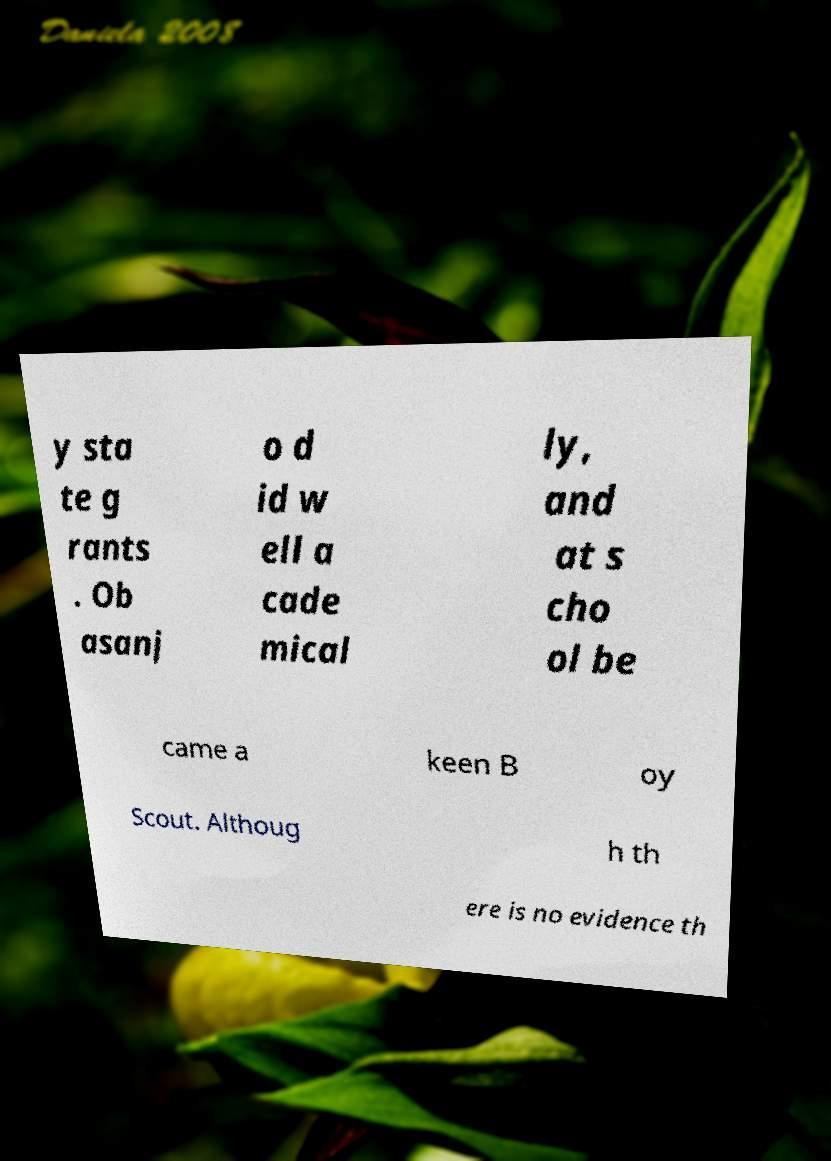Can you accurately transcribe the text from the provided image for me? y sta te g rants . Ob asanj o d id w ell a cade mical ly, and at s cho ol be came a keen B oy Scout. Althoug h th ere is no evidence th 